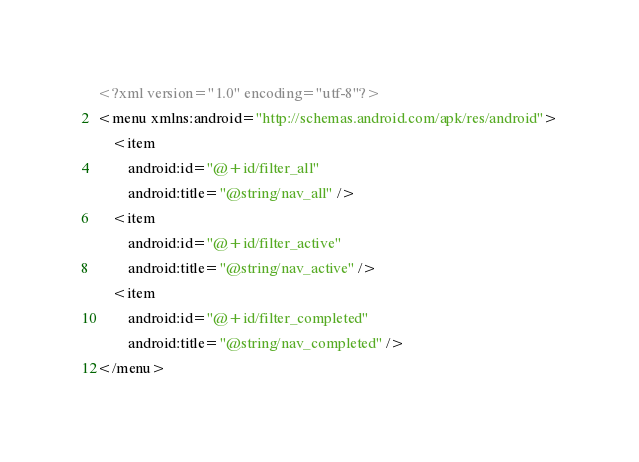Convert code to text. <code><loc_0><loc_0><loc_500><loc_500><_XML_><?xml version="1.0" encoding="utf-8"?>
<menu xmlns:android="http://schemas.android.com/apk/res/android">
    <item
        android:id="@+id/filter_all"
        android:title="@string/nav_all" />
    <item
        android:id="@+id/filter_active"
        android:title="@string/nav_active" />
    <item
        android:id="@+id/filter_completed"
        android:title="@string/nav_completed" />
</menu></code> 